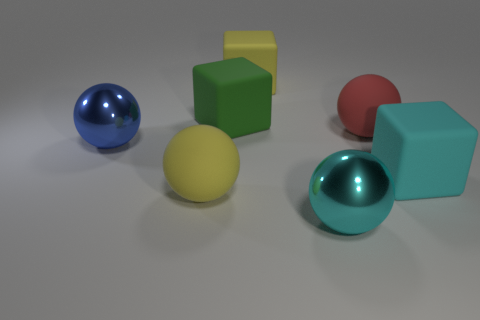Subtract all cyan matte blocks. How many blocks are left? 2 Subtract all red balls. How many balls are left? 3 Add 2 small brown shiny cylinders. How many objects exist? 9 Subtract all cyan spheres. Subtract all cyan cubes. How many spheres are left? 3 Subtract all cubes. How many objects are left? 4 Subtract 0 red cubes. How many objects are left? 7 Subtract all big green cubes. Subtract all cubes. How many objects are left? 3 Add 5 blue objects. How many blue objects are left? 6 Add 5 blue shiny spheres. How many blue shiny spheres exist? 6 